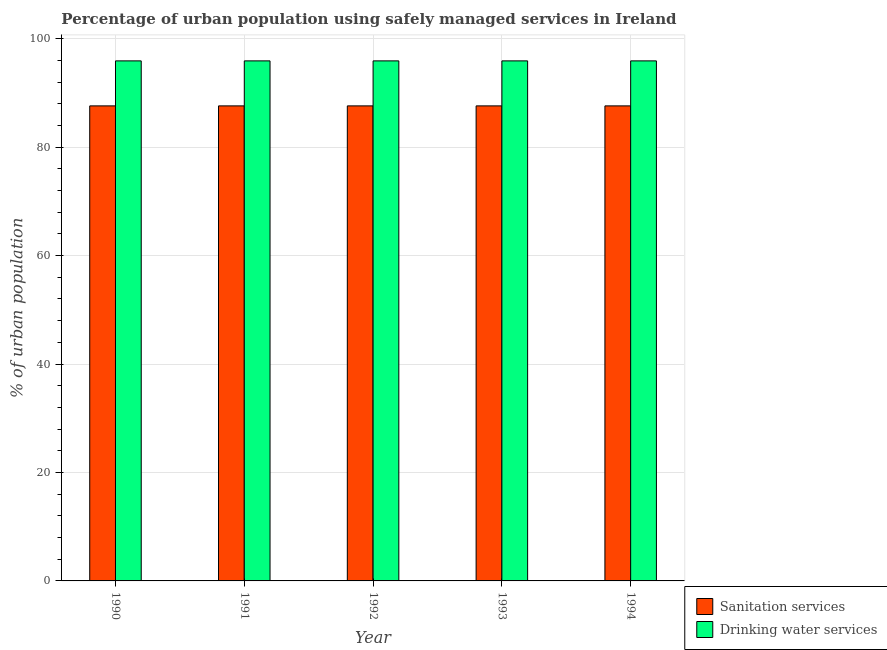How many different coloured bars are there?
Provide a short and direct response. 2. How many groups of bars are there?
Keep it short and to the point. 5. Are the number of bars on each tick of the X-axis equal?
Your answer should be very brief. Yes. How many bars are there on the 5th tick from the right?
Offer a terse response. 2. What is the label of the 3rd group of bars from the left?
Make the answer very short. 1992. What is the percentage of urban population who used drinking water services in 1993?
Your answer should be compact. 95.9. Across all years, what is the maximum percentage of urban population who used drinking water services?
Give a very brief answer. 95.9. Across all years, what is the minimum percentage of urban population who used drinking water services?
Give a very brief answer. 95.9. In which year was the percentage of urban population who used drinking water services maximum?
Provide a short and direct response. 1990. What is the total percentage of urban population who used drinking water services in the graph?
Your answer should be very brief. 479.5. What is the difference between the percentage of urban population who used drinking water services in 1992 and the percentage of urban population who used sanitation services in 1993?
Your response must be concise. 0. What is the average percentage of urban population who used sanitation services per year?
Offer a terse response. 87.6. What is the difference between the highest and the second highest percentage of urban population who used sanitation services?
Give a very brief answer. 0. What is the difference between the highest and the lowest percentage of urban population who used drinking water services?
Your answer should be compact. 0. In how many years, is the percentage of urban population who used drinking water services greater than the average percentage of urban population who used drinking water services taken over all years?
Offer a very short reply. 0. Is the sum of the percentage of urban population who used drinking water services in 1991 and 1992 greater than the maximum percentage of urban population who used sanitation services across all years?
Offer a terse response. Yes. What does the 1st bar from the left in 1991 represents?
Provide a succinct answer. Sanitation services. What does the 1st bar from the right in 1993 represents?
Offer a very short reply. Drinking water services. Are all the bars in the graph horizontal?
Provide a short and direct response. No. What is the difference between two consecutive major ticks on the Y-axis?
Provide a succinct answer. 20. Are the values on the major ticks of Y-axis written in scientific E-notation?
Offer a very short reply. No. Where does the legend appear in the graph?
Keep it short and to the point. Bottom right. How are the legend labels stacked?
Ensure brevity in your answer.  Vertical. What is the title of the graph?
Your answer should be compact. Percentage of urban population using safely managed services in Ireland. What is the label or title of the X-axis?
Provide a short and direct response. Year. What is the label or title of the Y-axis?
Provide a succinct answer. % of urban population. What is the % of urban population in Sanitation services in 1990?
Keep it short and to the point. 87.6. What is the % of urban population in Drinking water services in 1990?
Offer a very short reply. 95.9. What is the % of urban population of Sanitation services in 1991?
Offer a terse response. 87.6. What is the % of urban population in Drinking water services in 1991?
Your answer should be compact. 95.9. What is the % of urban population of Sanitation services in 1992?
Keep it short and to the point. 87.6. What is the % of urban population in Drinking water services in 1992?
Keep it short and to the point. 95.9. What is the % of urban population in Sanitation services in 1993?
Your response must be concise. 87.6. What is the % of urban population of Drinking water services in 1993?
Offer a very short reply. 95.9. What is the % of urban population of Sanitation services in 1994?
Offer a very short reply. 87.6. What is the % of urban population of Drinking water services in 1994?
Your response must be concise. 95.9. Across all years, what is the maximum % of urban population in Sanitation services?
Make the answer very short. 87.6. Across all years, what is the maximum % of urban population of Drinking water services?
Provide a short and direct response. 95.9. Across all years, what is the minimum % of urban population in Sanitation services?
Your answer should be very brief. 87.6. Across all years, what is the minimum % of urban population of Drinking water services?
Provide a succinct answer. 95.9. What is the total % of urban population of Sanitation services in the graph?
Give a very brief answer. 438. What is the total % of urban population of Drinking water services in the graph?
Ensure brevity in your answer.  479.5. What is the difference between the % of urban population in Sanitation services in 1990 and that in 1992?
Ensure brevity in your answer.  0. What is the difference between the % of urban population of Drinking water services in 1990 and that in 1992?
Provide a short and direct response. 0. What is the difference between the % of urban population of Sanitation services in 1990 and that in 1993?
Provide a succinct answer. 0. What is the difference between the % of urban population in Drinking water services in 1990 and that in 1994?
Your response must be concise. 0. What is the difference between the % of urban population of Sanitation services in 1991 and that in 1992?
Keep it short and to the point. 0. What is the difference between the % of urban population in Drinking water services in 1991 and that in 1993?
Offer a very short reply. 0. What is the difference between the % of urban population of Drinking water services in 1991 and that in 1994?
Provide a short and direct response. 0. What is the difference between the % of urban population in Sanitation services in 1992 and that in 1993?
Offer a very short reply. 0. What is the difference between the % of urban population in Drinking water services in 1992 and that in 1993?
Your answer should be compact. 0. What is the difference between the % of urban population of Sanitation services in 1992 and that in 1994?
Keep it short and to the point. 0. What is the difference between the % of urban population in Sanitation services in 1993 and that in 1994?
Offer a terse response. 0. What is the difference between the % of urban population in Sanitation services in 1990 and the % of urban population in Drinking water services in 1991?
Offer a terse response. -8.3. What is the difference between the % of urban population in Sanitation services in 1990 and the % of urban population in Drinking water services in 1992?
Offer a terse response. -8.3. What is the difference between the % of urban population in Sanitation services in 1990 and the % of urban population in Drinking water services in 1994?
Give a very brief answer. -8.3. What is the difference between the % of urban population of Sanitation services in 1991 and the % of urban population of Drinking water services in 1992?
Ensure brevity in your answer.  -8.3. What is the difference between the % of urban population of Sanitation services in 1991 and the % of urban population of Drinking water services in 1994?
Provide a succinct answer. -8.3. What is the difference between the % of urban population in Sanitation services in 1992 and the % of urban population in Drinking water services in 1994?
Your response must be concise. -8.3. What is the difference between the % of urban population in Sanitation services in 1993 and the % of urban population in Drinking water services in 1994?
Ensure brevity in your answer.  -8.3. What is the average % of urban population of Sanitation services per year?
Offer a terse response. 87.6. What is the average % of urban population of Drinking water services per year?
Keep it short and to the point. 95.9. In the year 1990, what is the difference between the % of urban population in Sanitation services and % of urban population in Drinking water services?
Your answer should be very brief. -8.3. In the year 1992, what is the difference between the % of urban population in Sanitation services and % of urban population in Drinking water services?
Offer a terse response. -8.3. In the year 1993, what is the difference between the % of urban population in Sanitation services and % of urban population in Drinking water services?
Your answer should be very brief. -8.3. In the year 1994, what is the difference between the % of urban population of Sanitation services and % of urban population of Drinking water services?
Your answer should be very brief. -8.3. What is the ratio of the % of urban population of Drinking water services in 1990 to that in 1991?
Keep it short and to the point. 1. What is the ratio of the % of urban population of Sanitation services in 1990 to that in 1992?
Provide a succinct answer. 1. What is the ratio of the % of urban population of Drinking water services in 1990 to that in 1992?
Make the answer very short. 1. What is the ratio of the % of urban population of Sanitation services in 1990 to that in 1993?
Make the answer very short. 1. What is the ratio of the % of urban population of Drinking water services in 1990 to that in 1993?
Your answer should be compact. 1. What is the ratio of the % of urban population in Drinking water services in 1990 to that in 1994?
Make the answer very short. 1. What is the ratio of the % of urban population in Drinking water services in 1991 to that in 1992?
Offer a terse response. 1. What is the ratio of the % of urban population in Sanitation services in 1991 to that in 1993?
Offer a terse response. 1. What is the ratio of the % of urban population in Drinking water services in 1991 to that in 1994?
Provide a short and direct response. 1. What is the ratio of the % of urban population in Sanitation services in 1992 to that in 1993?
Offer a very short reply. 1. What is the ratio of the % of urban population in Sanitation services in 1993 to that in 1994?
Your answer should be compact. 1. What is the ratio of the % of urban population in Drinking water services in 1993 to that in 1994?
Make the answer very short. 1. What is the difference between the highest and the second highest % of urban population in Sanitation services?
Provide a succinct answer. 0. What is the difference between the highest and the second highest % of urban population of Drinking water services?
Give a very brief answer. 0. What is the difference between the highest and the lowest % of urban population of Sanitation services?
Your answer should be compact. 0. What is the difference between the highest and the lowest % of urban population of Drinking water services?
Your answer should be compact. 0. 